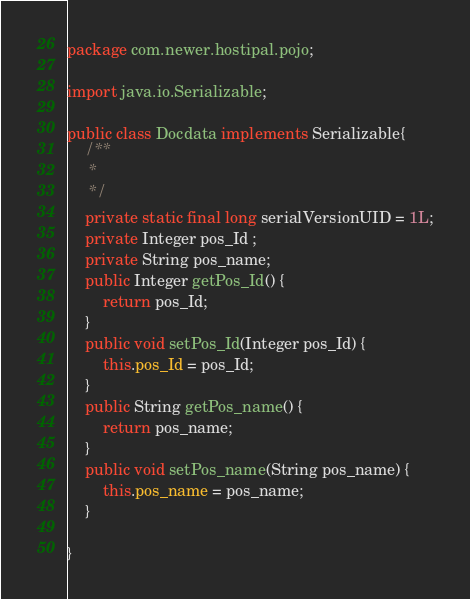<code> <loc_0><loc_0><loc_500><loc_500><_Java_>package com.newer.hostipal.pojo;

import java.io.Serializable;

public class Docdata implements Serializable{
	/**
	 * 
	 */
	private static final long serialVersionUID = 1L;
	private Integer pos_Id ;
	private String pos_name;
	public Integer getPos_Id() {
		return pos_Id;
	}
	public void setPos_Id(Integer pos_Id) {
		this.pos_Id = pos_Id;
	}
	public String getPos_name() {
		return pos_name;
	}
	public void setPos_name(String pos_name) {
		this.pos_name = pos_name;
	}
	
}
</code> 